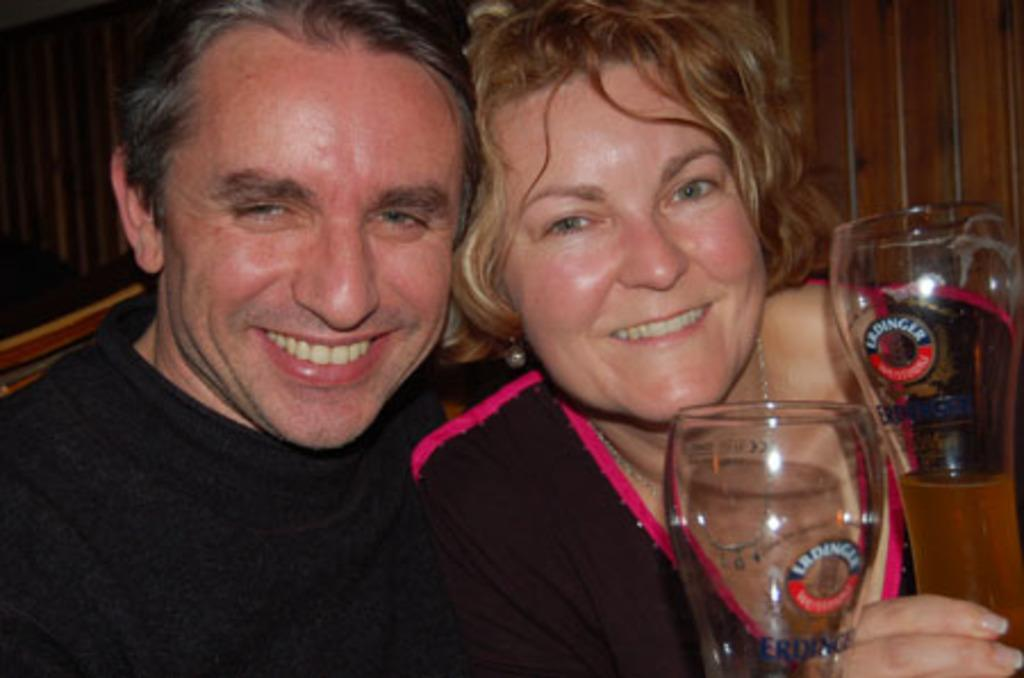What is the man in the image wearing? The man is wearing a black dress. What is the woman in the image wearing? The woman is wearing a black dress. What expressions do the man and woman have in the image? The man and woman are both smiling in the image. What are the man and woman holding in the image? The man and woman are holding glasses with juice. What type of crime is being committed by the man and woman in the image? There is no crime being committed in the image; the man and woman are both smiling and holding glasses with juice. What kind of beef is being served at the table in the image? There is no beef present in the image; the man and woman are holding glasses with juice. 